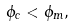<formula> <loc_0><loc_0><loc_500><loc_500>\phi _ { c } < \phi _ { m } ,</formula> 